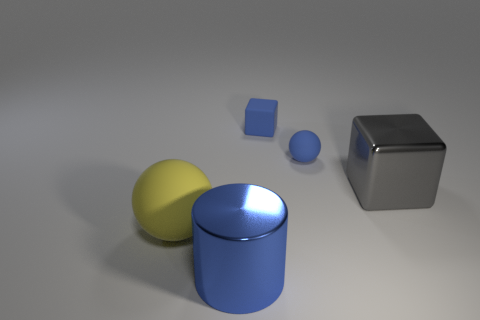Are there more blue objects than shiny cylinders?
Give a very brief answer. Yes. What is the size of the yellow sphere?
Offer a very short reply. Large. What number of other things are there of the same color as the tiny rubber ball?
Offer a very short reply. 2. Do the large gray thing on the right side of the large cylinder and the tiny cube have the same material?
Your response must be concise. No. Is the number of objects in front of the large gray block less than the number of objects behind the big ball?
Your answer should be compact. Yes. What number of other objects are there of the same material as the cylinder?
Ensure brevity in your answer.  1. There is a blue object that is the same size as the blue block; what is it made of?
Provide a short and direct response. Rubber. Are there fewer matte objects that are in front of the tiny sphere than rubber objects?
Ensure brevity in your answer.  Yes. There is a shiny thing that is behind the sphere that is left of the shiny object to the left of the gray metal thing; what shape is it?
Make the answer very short. Cube. There is a shiny object to the right of the small ball; what is its size?
Offer a terse response. Large. 